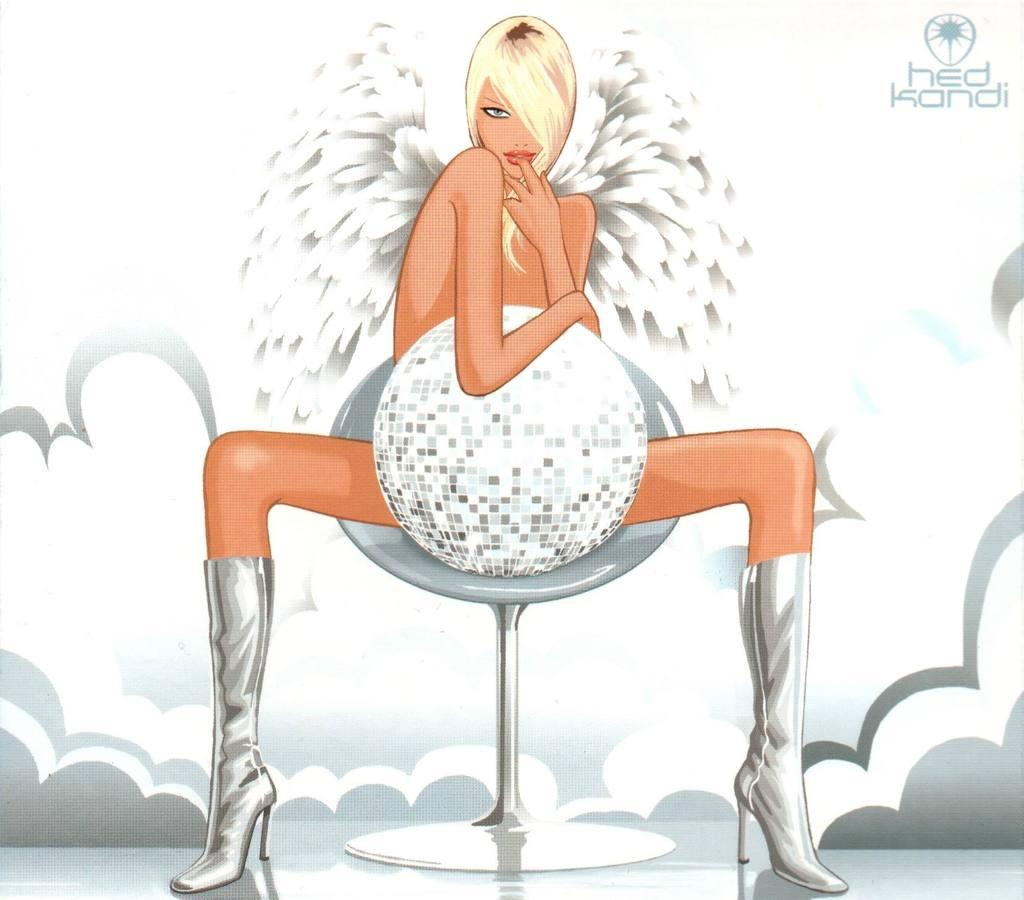What style is the image in? The image is a cartoon. Who is present in the image? There is a woman in the image. What is the woman doing in the image? The woman is seated on a chair and holding a ball. Is there any text or symbol in the image? Yes, there is a logo in the top right corner of the image. What type of tax is being discussed in the image? There is no discussion of tax in the image; it is a cartoon featuring a woman seated on a chair and holding a ball. What kind of cloth is draped over the chair in the image? There is no cloth draped over the chair in the image; the woman is seated on a plain chair. 